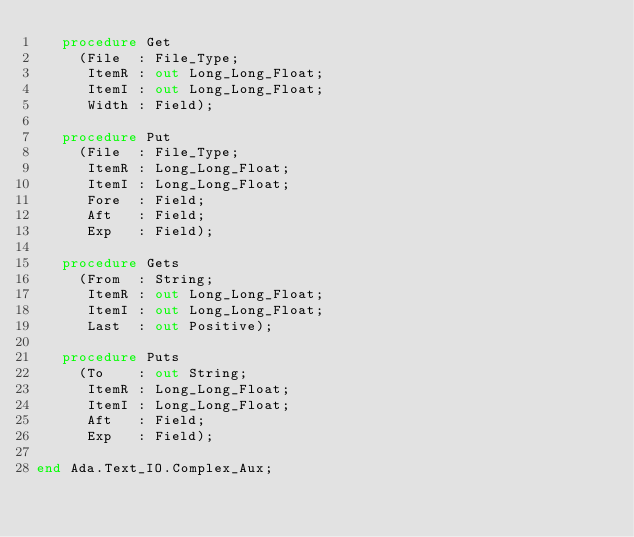<code> <loc_0><loc_0><loc_500><loc_500><_Ada_>   procedure Get
     (File  : File_Type;
      ItemR : out Long_Long_Float;
      ItemI : out Long_Long_Float;
      Width : Field);

   procedure Put
     (File  : File_Type;
      ItemR : Long_Long_Float;
      ItemI : Long_Long_Float;
      Fore  : Field;
      Aft   : Field;
      Exp   : Field);

   procedure Gets
     (From  : String;
      ItemR : out Long_Long_Float;
      ItemI : out Long_Long_Float;
      Last  : out Positive);

   procedure Puts
     (To    : out String;
      ItemR : Long_Long_Float;
      ItemI : Long_Long_Float;
      Aft   : Field;
      Exp   : Field);

end Ada.Text_IO.Complex_Aux;
</code> 